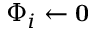Convert formula to latex. <formula><loc_0><loc_0><loc_500><loc_500>{ \Phi _ { i } } \gets 0</formula> 